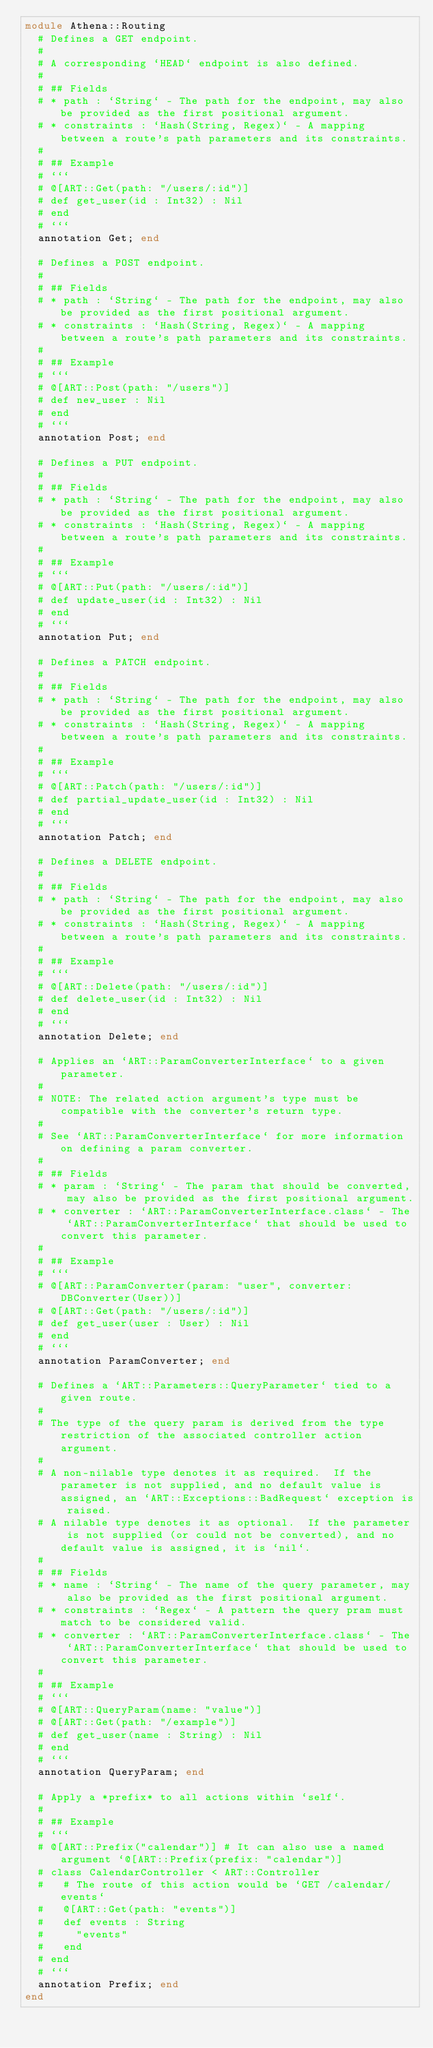Convert code to text. <code><loc_0><loc_0><loc_500><loc_500><_Crystal_>module Athena::Routing
  # Defines a GET endpoint.
  #
  # A corresponding `HEAD` endpoint is also defined.
  #
  # ## Fields
  # * path : `String` - The path for the endpoint, may also be provided as the first positional argument.
  # * constraints : `Hash(String, Regex)` - A mapping between a route's path parameters and its constraints.
  #
  # ## Example
  # ```
  # @[ART::Get(path: "/users/:id")]
  # def get_user(id : Int32) : Nil
  # end
  # ```
  annotation Get; end

  # Defines a POST endpoint.
  #
  # ## Fields
  # * path : `String` - The path for the endpoint, may also be provided as the first positional argument.
  # * constraints : `Hash(String, Regex)` - A mapping between a route's path parameters and its constraints.
  #
  # ## Example
  # ```
  # @[ART::Post(path: "/users")]
  # def new_user : Nil
  # end
  # ```
  annotation Post; end

  # Defines a PUT endpoint.
  #
  # ## Fields
  # * path : `String` - The path for the endpoint, may also be provided as the first positional argument.
  # * constraints : `Hash(String, Regex)` - A mapping between a route's path parameters and its constraints.
  #
  # ## Example
  # ```
  # @[ART::Put(path: "/users/:id")]
  # def update_user(id : Int32) : Nil
  # end
  # ```
  annotation Put; end

  # Defines a PATCH endpoint.
  #
  # ## Fields
  # * path : `String` - The path for the endpoint, may also be provided as the first positional argument.
  # * constraints : `Hash(String, Regex)` - A mapping between a route's path parameters and its constraints.
  #
  # ## Example
  # ```
  # @[ART::Patch(path: "/users/:id")]
  # def partial_update_user(id : Int32) : Nil
  # end
  # ```
  annotation Patch; end

  # Defines a DELETE endpoint.
  #
  # ## Fields
  # * path : `String` - The path for the endpoint, may also be provided as the first positional argument.
  # * constraints : `Hash(String, Regex)` - A mapping between a route's path parameters and its constraints.
  #
  # ## Example
  # ```
  # @[ART::Delete(path: "/users/:id")]
  # def delete_user(id : Int32) : Nil
  # end
  # ```
  annotation Delete; end

  # Applies an `ART::ParamConverterInterface` to a given parameter.
  #
  # NOTE: The related action argument's type must be compatible with the converter's return type.
  #
  # See `ART::ParamConverterInterface` for more information on defining a param converter.
  #
  # ## Fields
  # * param : `String` - The param that should be converted, may also be provided as the first positional argument.
  # * converter : `ART::ParamConverterInterface.class` - The `ART::ParamConverterInterface` that should be used to convert this parameter.
  #
  # ## Example
  # ```
  # @[ART::ParamConverter(param: "user", converter: DBConverter(User))]
  # @[ART::Get(path: "/users/:id")]
  # def get_user(user : User) : Nil
  # end
  # ```
  annotation ParamConverter; end

  # Defines a `ART::Parameters::QueryParameter` tied to a given route.
  #
  # The type of the query param is derived from the type restriction of the associated controller action argument.
  #
  # A non-nilable type denotes it as required.  If the parameter is not supplied, and no default value is assigned, an `ART::Exceptions::BadRequest` exception is raised.
  # A nilable type denotes it as optional.  If the parameter is not supplied (or could not be converted), and no default value is assigned, it is `nil`.
  #
  # ## Fields
  # * name : `String` - The name of the query parameter, may also be provided as the first positional argument.
  # * constraints : `Regex` - A pattern the query pram must match to be considered valid.
  # * converter : `ART::ParamConverterInterface.class` - The `ART::ParamConverterInterface` that should be used to convert this parameter.
  #
  # ## Example
  # ```
  # @[ART::QueryParam(name: "value")]
  # @[ART::Get(path: "/example")]
  # def get_user(name : String) : Nil
  # end
  # ```
  annotation QueryParam; end

  # Apply a *prefix* to all actions within `self`.
  #
  # ## Example
  # ```
  # @[ART::Prefix("calendar")] # It can also use a named argument `@[ART::Prefix(prefix: "calendar")]
  # class CalendarController < ART::Controller
  #   # The route of this action would be `GET /calendar/events`
  #   @[ART::Get(path: "events")]
  #   def events : String
  #     "events"
  #   end
  # end
  # ```
  annotation Prefix; end
end
</code> 